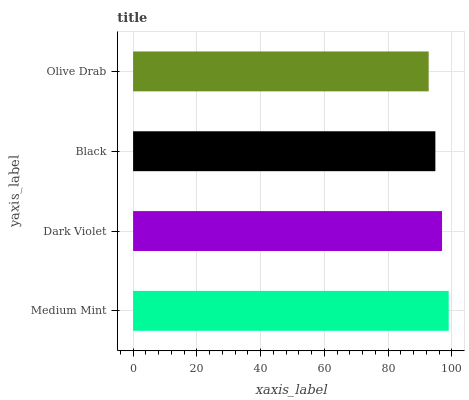Is Olive Drab the minimum?
Answer yes or no. Yes. Is Medium Mint the maximum?
Answer yes or no. Yes. Is Dark Violet the minimum?
Answer yes or no. No. Is Dark Violet the maximum?
Answer yes or no. No. Is Medium Mint greater than Dark Violet?
Answer yes or no. Yes. Is Dark Violet less than Medium Mint?
Answer yes or no. Yes. Is Dark Violet greater than Medium Mint?
Answer yes or no. No. Is Medium Mint less than Dark Violet?
Answer yes or no. No. Is Dark Violet the high median?
Answer yes or no. Yes. Is Black the low median?
Answer yes or no. Yes. Is Olive Drab the high median?
Answer yes or no. No. Is Dark Violet the low median?
Answer yes or no. No. 